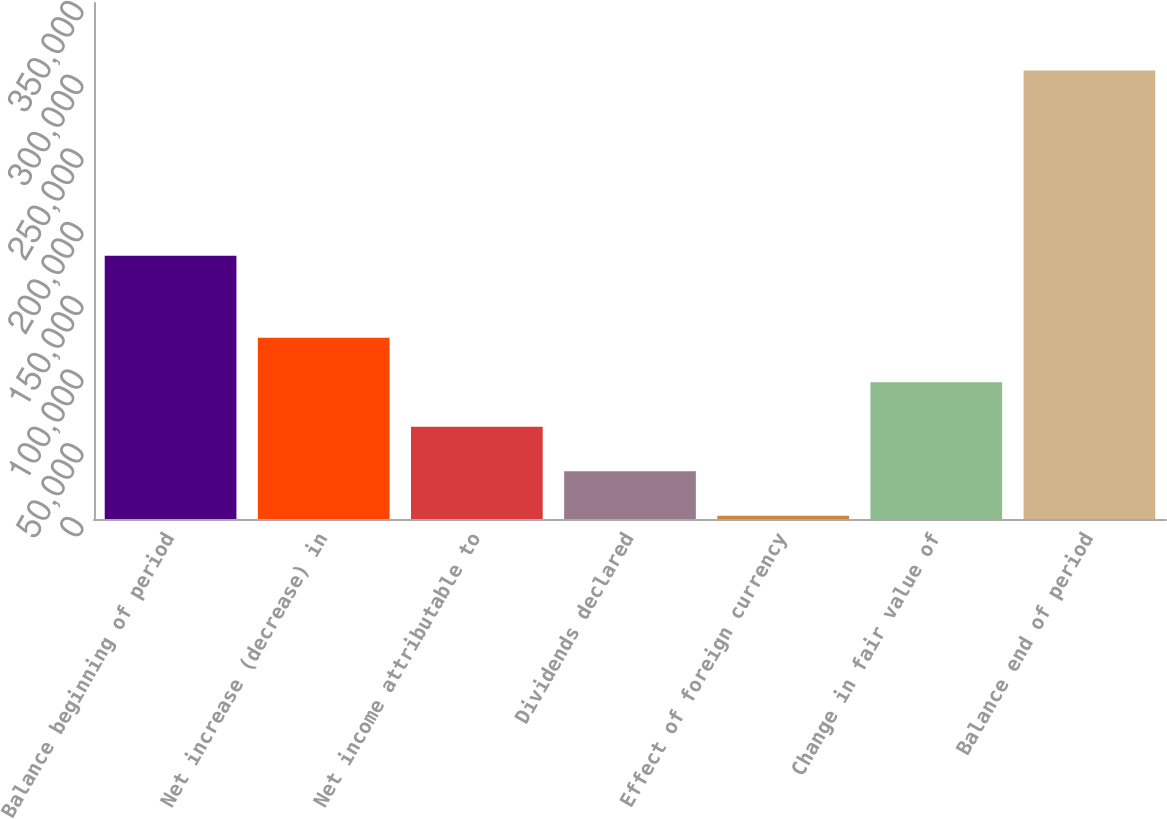Convert chart to OTSL. <chart><loc_0><loc_0><loc_500><loc_500><bar_chart><fcel>Balance beginning of period<fcel>Net increase (decrease) in<fcel>Net income attributable to<fcel>Dividends declared<fcel>Effect of foreign currency<fcel>Change in fair value of<fcel>Balance end of period<nl><fcel>178570<fcel>123025<fcel>62652.8<fcel>32466.9<fcel>2281<fcel>92838.7<fcel>304140<nl></chart> 